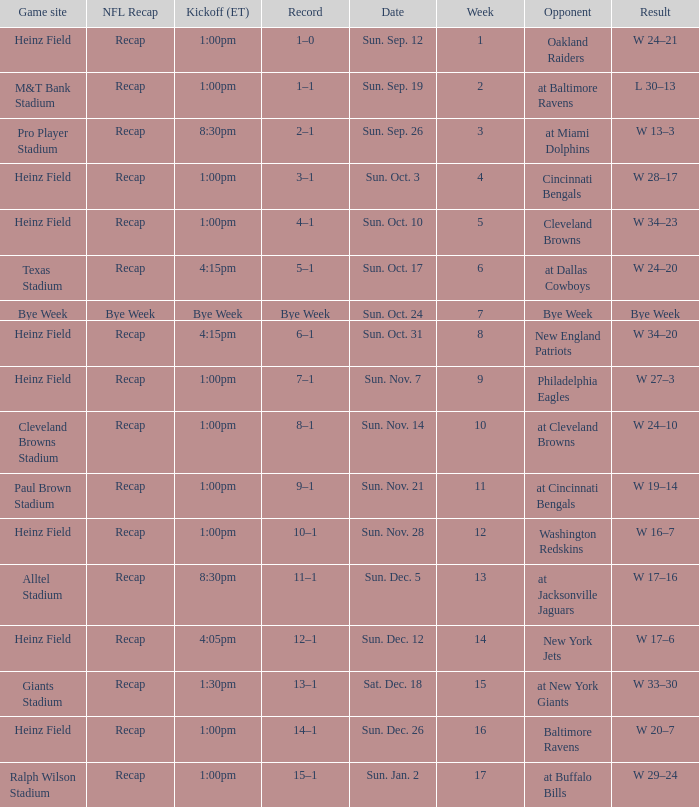Which Kickoff (ET) has a Result of w 34–23? 1:00pm. 